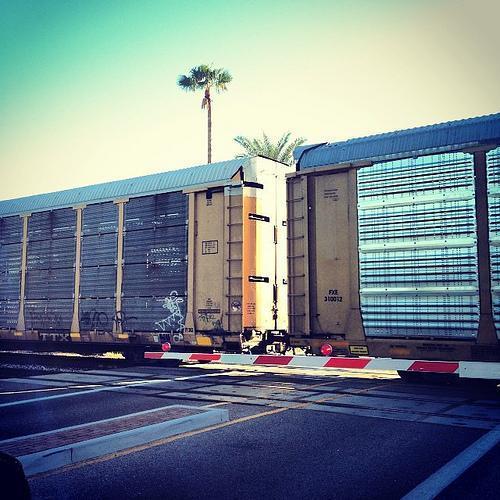How many of the stripes are red?
Give a very brief answer. 5. 